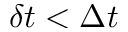<formula> <loc_0><loc_0><loc_500><loc_500>\delta t < \Delta t</formula> 